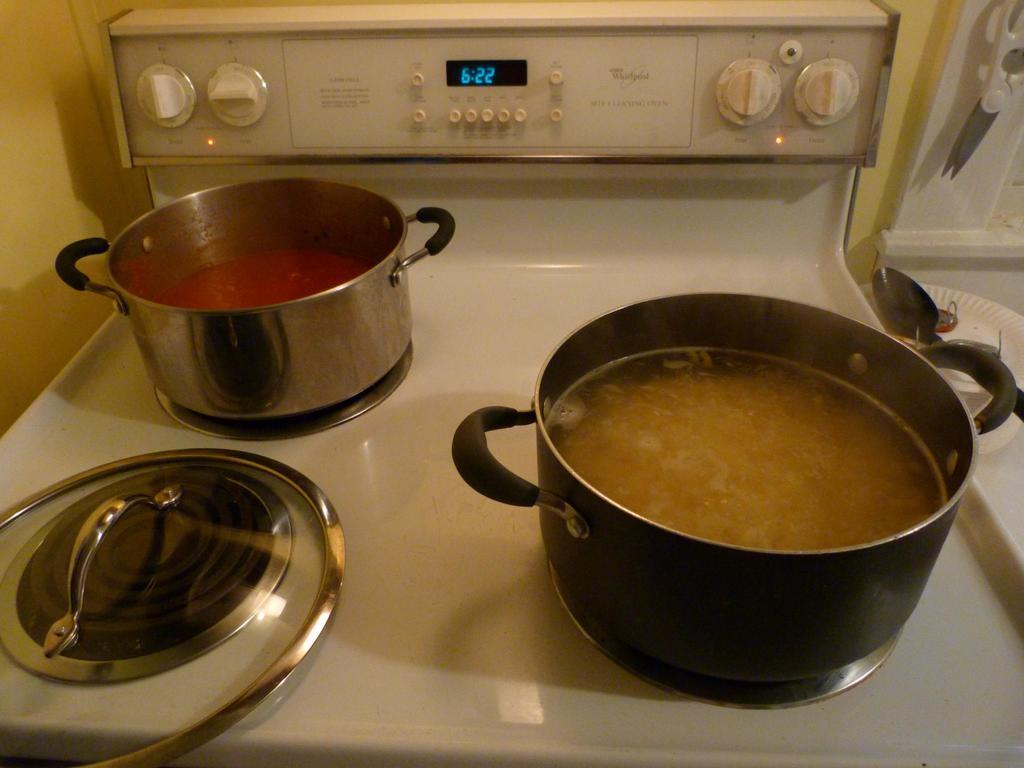<image>
Relay a brief, clear account of the picture shown. Pots filled with different sauces sit on a stove as the clock shows the time as 6:22. 